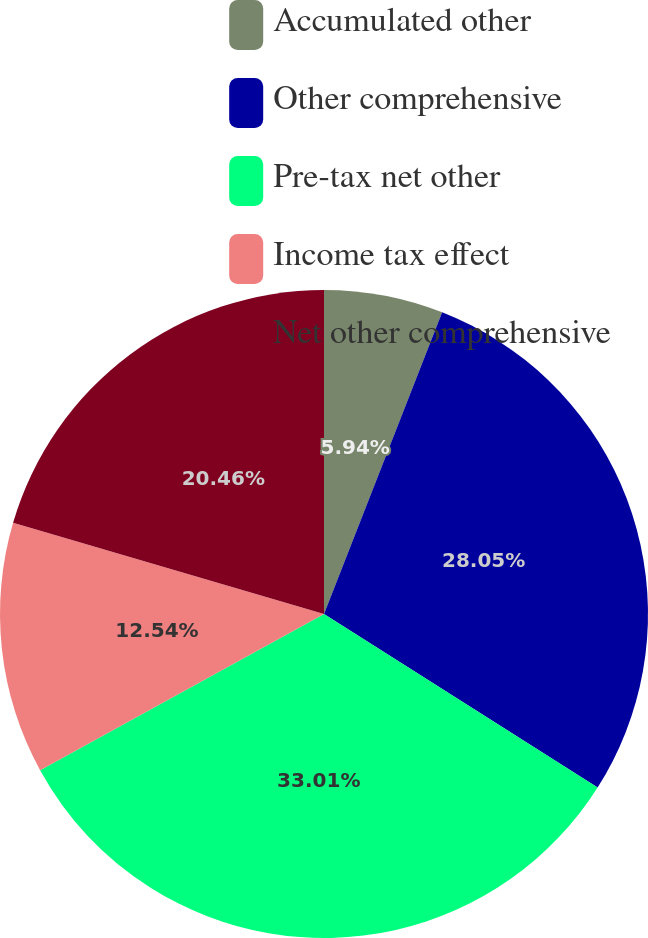<chart> <loc_0><loc_0><loc_500><loc_500><pie_chart><fcel>Accumulated other<fcel>Other comprehensive<fcel>Pre-tax net other<fcel>Income tax effect<fcel>Net other comprehensive<nl><fcel>5.94%<fcel>28.05%<fcel>33.0%<fcel>12.54%<fcel>20.46%<nl></chart> 